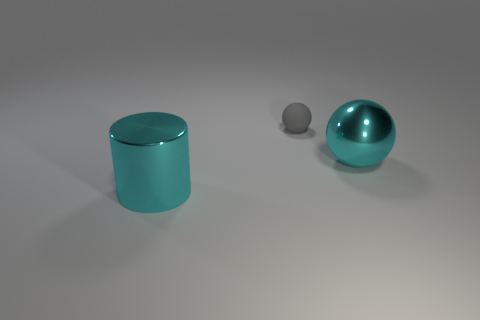What material is the big cyan thing behind the large cyan metal cylinder?
Offer a terse response. Metal. What is the color of the metal sphere?
Make the answer very short. Cyan. There is a cyan object behind the cylinder; is it the same size as the thing left of the small gray rubber thing?
Your response must be concise. Yes. How big is the thing that is both right of the cylinder and in front of the tiny ball?
Offer a terse response. Large. What is the color of the metal object that is the same shape as the rubber thing?
Provide a succinct answer. Cyan. Are there more small gray balls on the right side of the metal ball than shiny objects in front of the big shiny cylinder?
Provide a succinct answer. No. What number of other objects are there of the same shape as the tiny gray matte thing?
Offer a terse response. 1. Is there a tiny thing that is behind the thing on the left side of the small sphere?
Offer a terse response. Yes. How many gray balls are there?
Provide a succinct answer. 1. There is a small rubber sphere; is its color the same as the large object to the left of the big shiny sphere?
Give a very brief answer. No. 